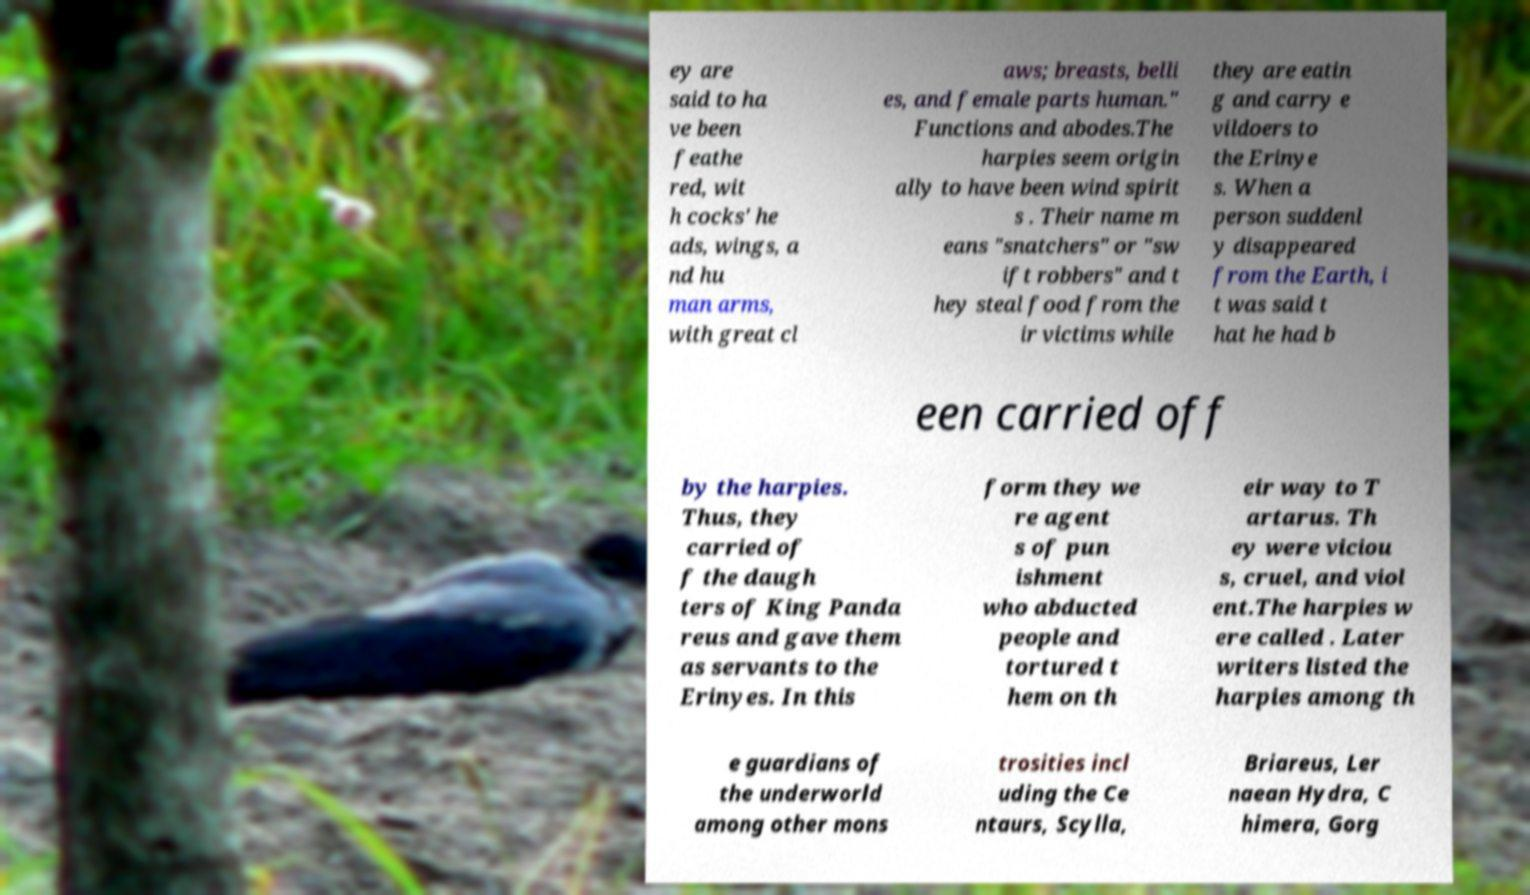There's text embedded in this image that I need extracted. Can you transcribe it verbatim? ey are said to ha ve been feathe red, wit h cocks' he ads, wings, a nd hu man arms, with great cl aws; breasts, belli es, and female parts human." Functions and abodes.The harpies seem origin ally to have been wind spirit s . Their name m eans "snatchers" or "sw ift robbers" and t hey steal food from the ir victims while they are eatin g and carry e vildoers to the Erinye s. When a person suddenl y disappeared from the Earth, i t was said t hat he had b een carried off by the harpies. Thus, they carried of f the daugh ters of King Panda reus and gave them as servants to the Erinyes. In this form they we re agent s of pun ishment who abducted people and tortured t hem on th eir way to T artarus. Th ey were viciou s, cruel, and viol ent.The harpies w ere called . Later writers listed the harpies among th e guardians of the underworld among other mons trosities incl uding the Ce ntaurs, Scylla, Briareus, Ler naean Hydra, C himera, Gorg 